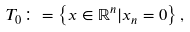Convert formula to latex. <formula><loc_0><loc_0><loc_500><loc_500>T _ { 0 } \colon = \left \{ x \in \mathbb { R } ^ { n } | x _ { n } = 0 \right \} ,</formula> 